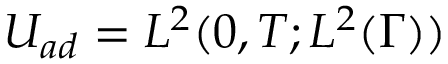<formula> <loc_0><loc_0><loc_500><loc_500>U _ { a d } = L ^ { 2 } ( 0 , T ; L ^ { 2 } ( \Gamma ) )</formula> 